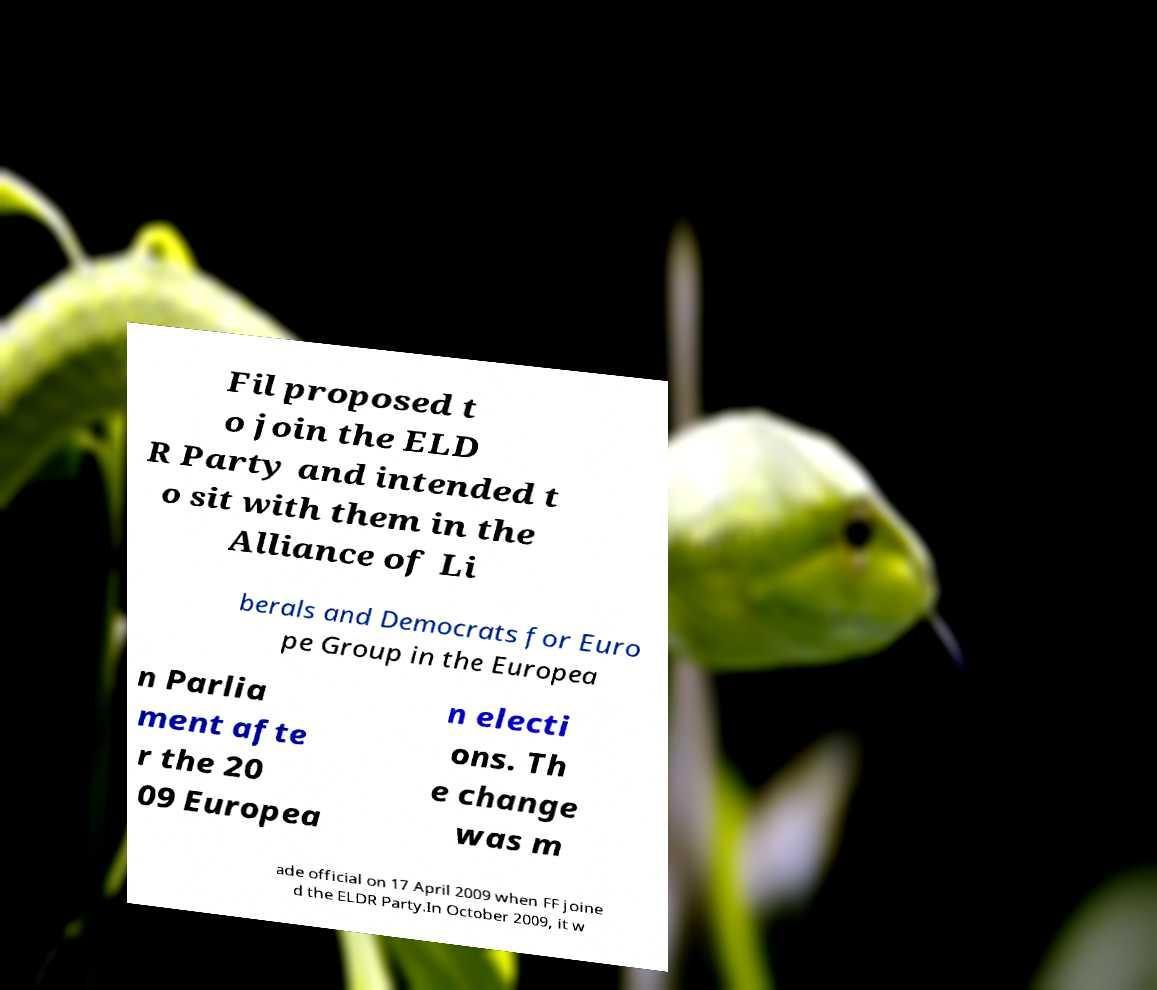Can you accurately transcribe the text from the provided image for me? Fil proposed t o join the ELD R Party and intended t o sit with them in the Alliance of Li berals and Democrats for Euro pe Group in the Europea n Parlia ment afte r the 20 09 Europea n electi ons. Th e change was m ade official on 17 April 2009 when FF joine d the ELDR Party.In October 2009, it w 